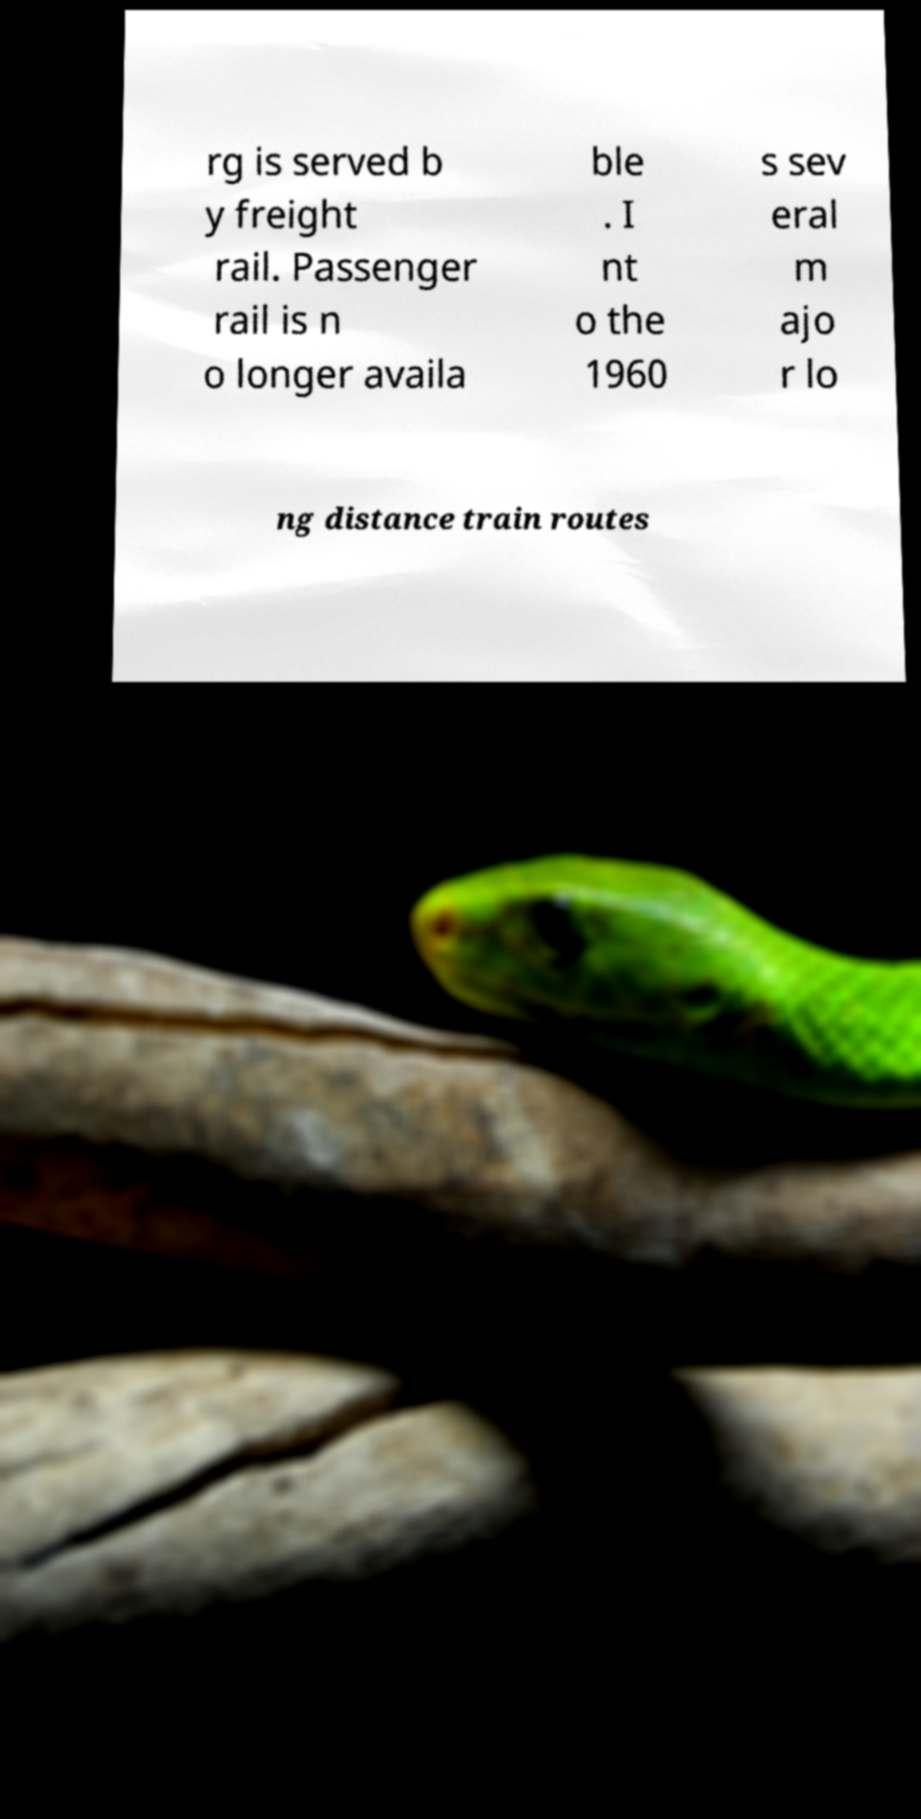Please identify and transcribe the text found in this image. rg is served b y freight rail. Passenger rail is n o longer availa ble . I nt o the 1960 s sev eral m ajo r lo ng distance train routes 